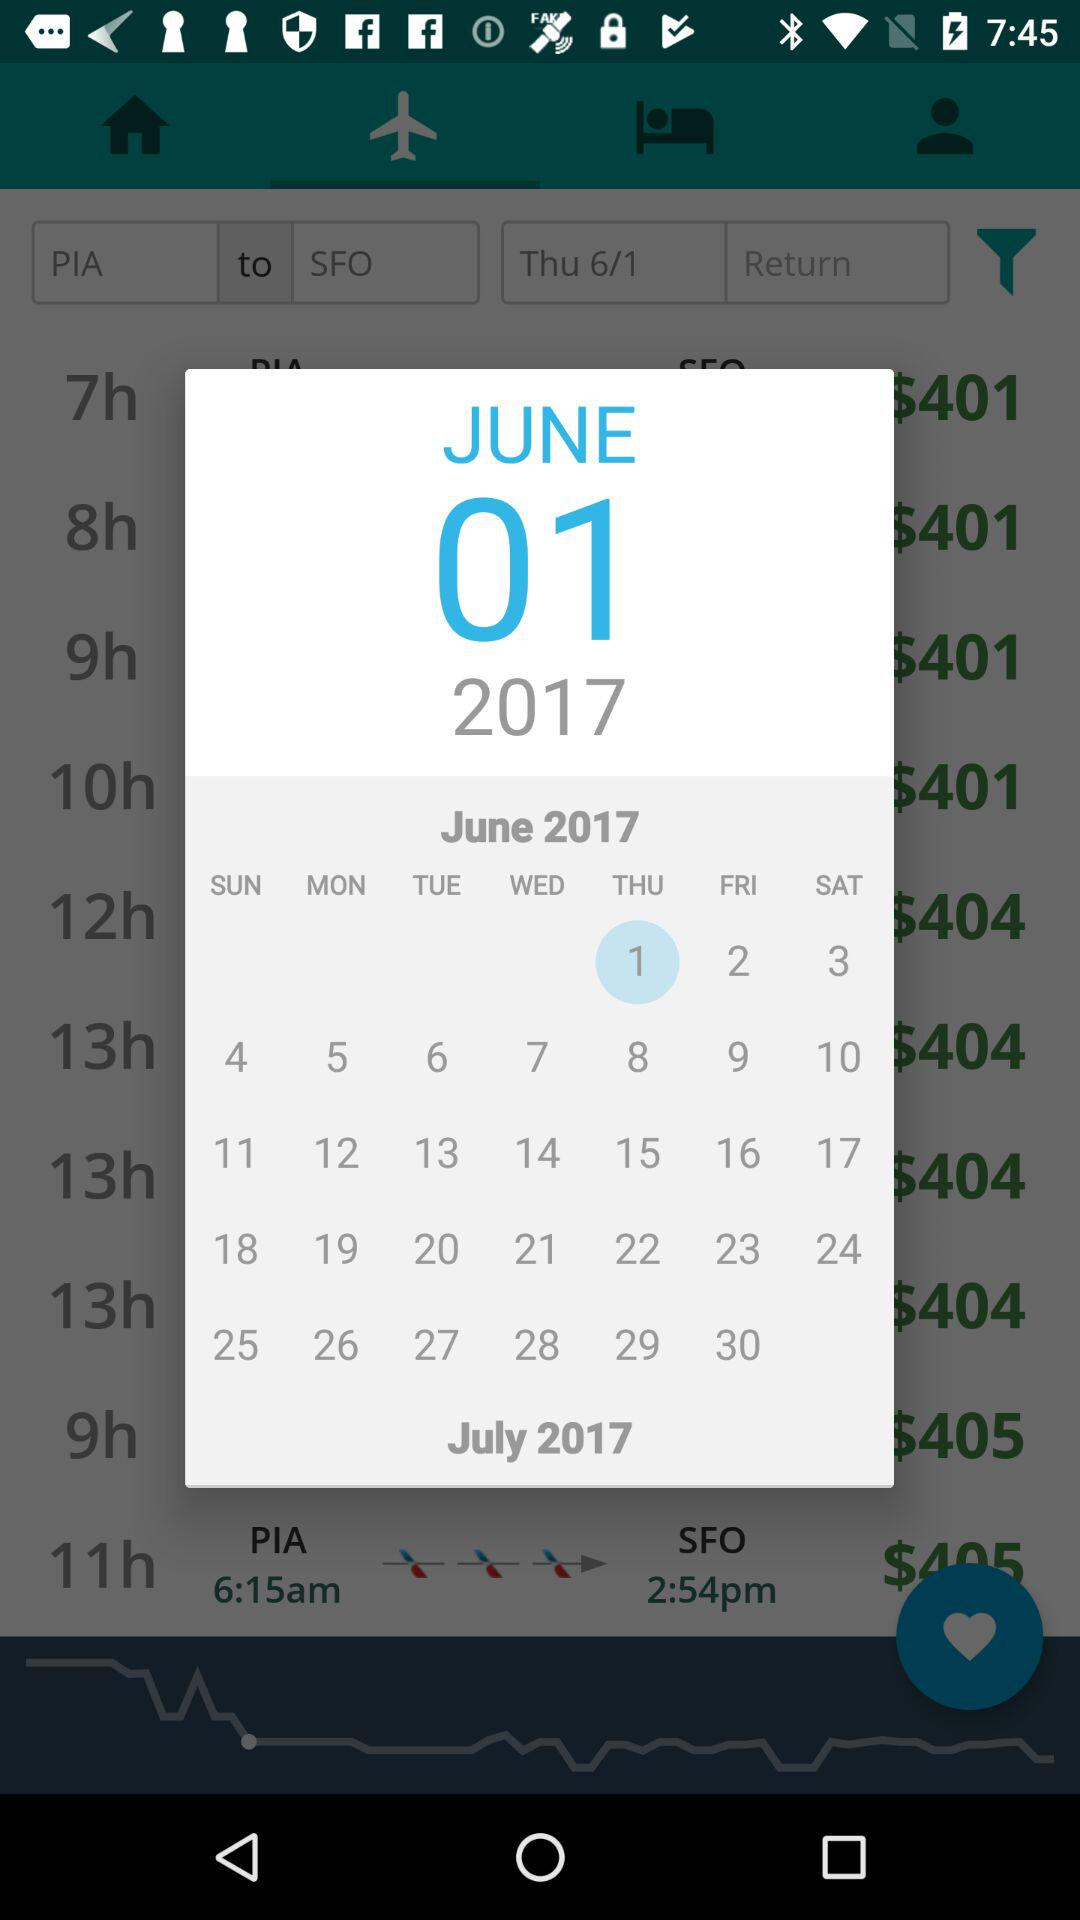Which month is selected for traveling? The month that is selected for traveling is June. 